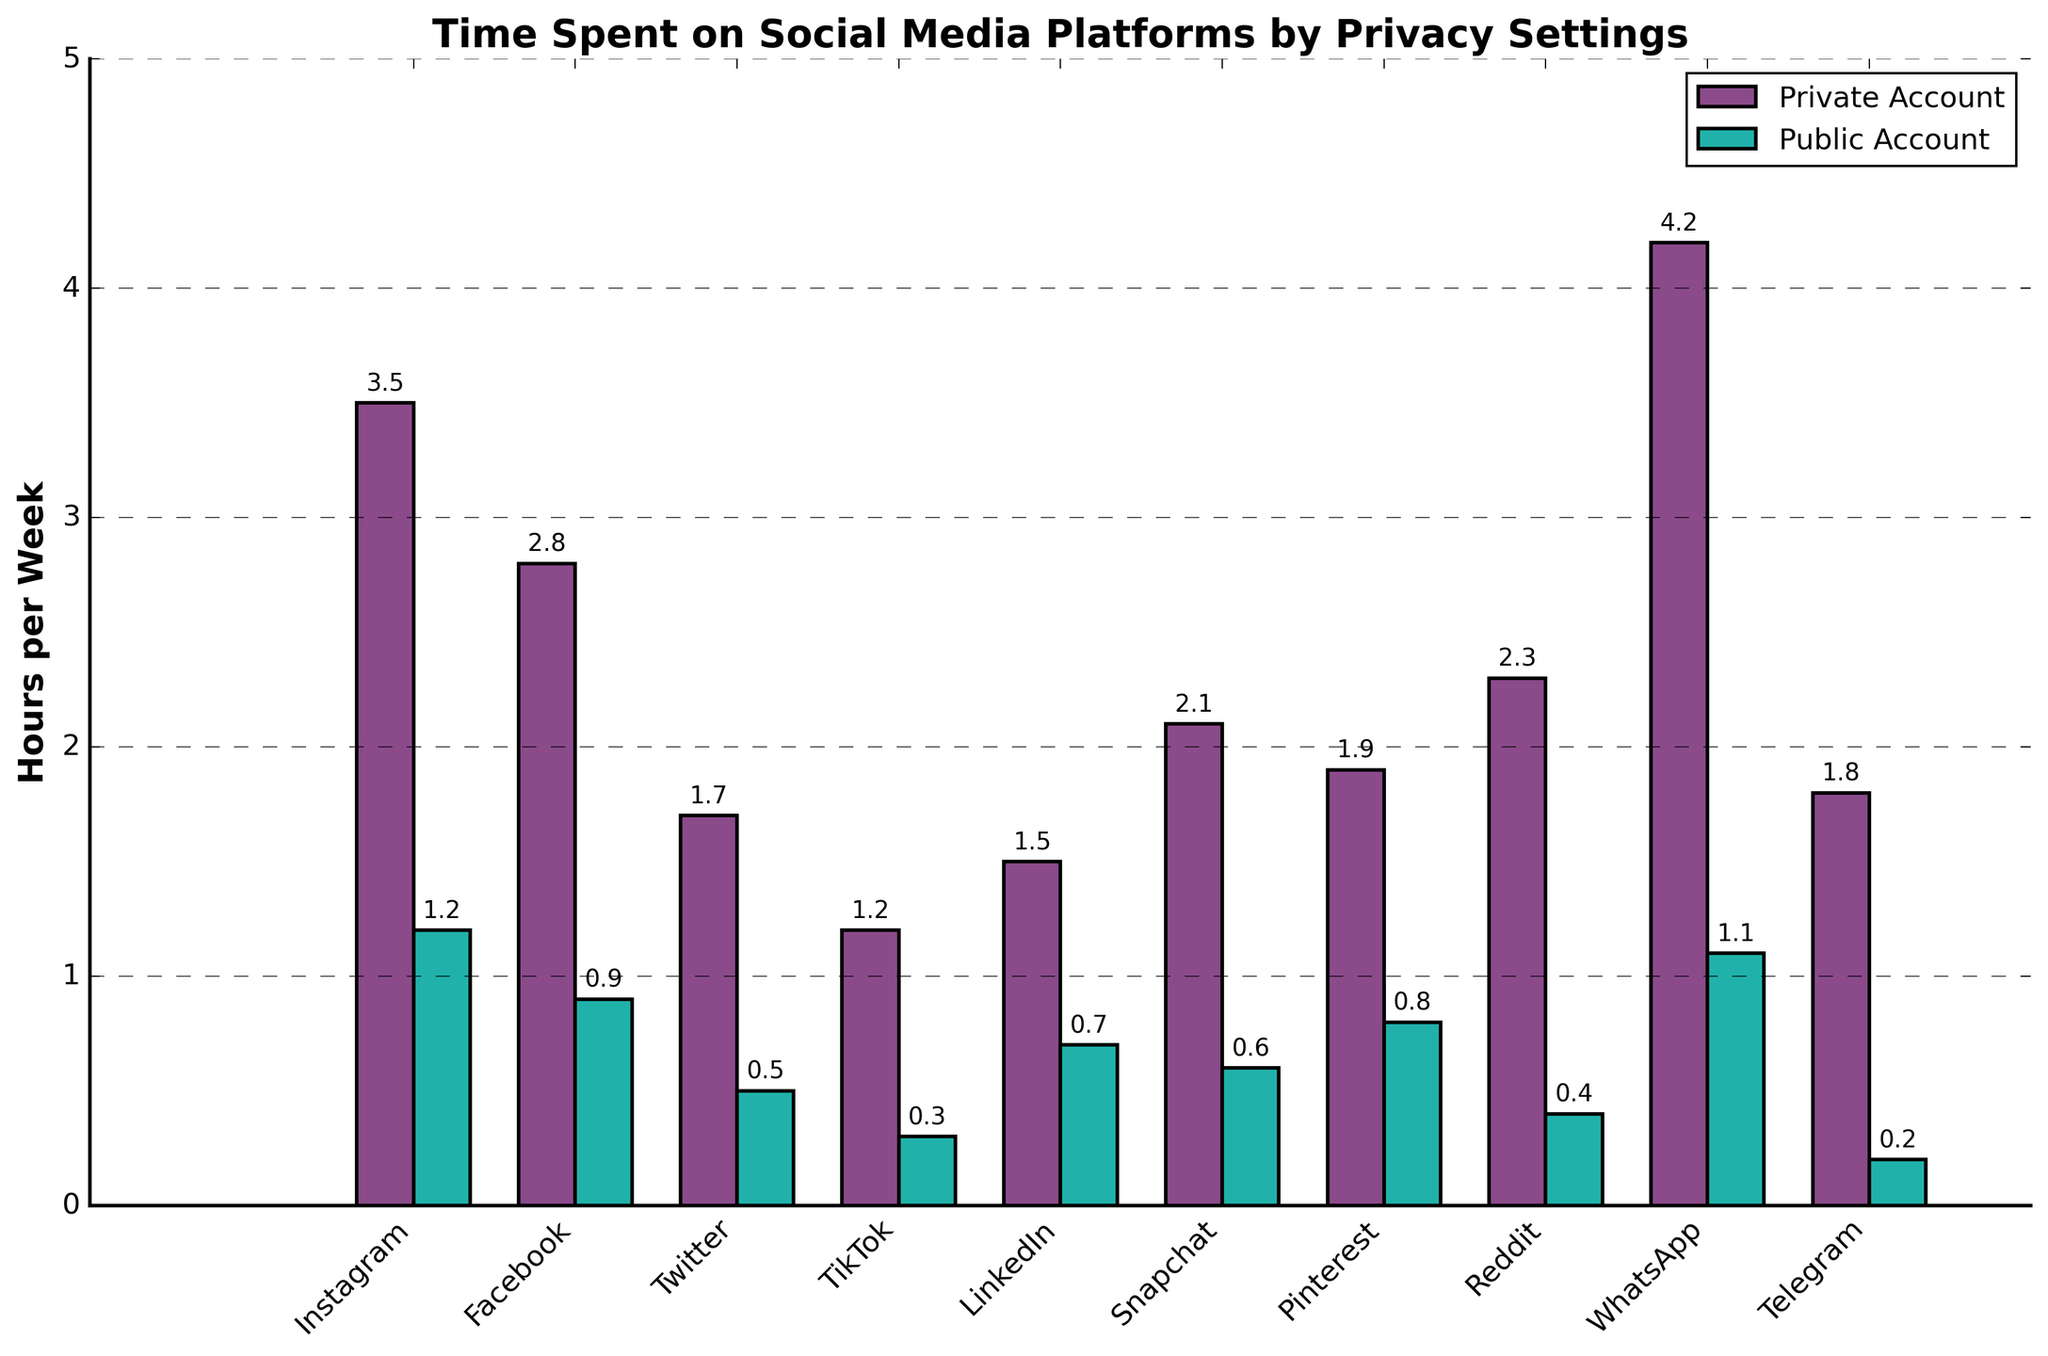Which platform has the highest time spent on private accounts? By visually comparing the heights of the bars for private accounts, the highest bar corresponds to WhatsApp.
Answer: WhatsApp Which platform shows the biggest difference in time spent between private and public accounts? Calculate the difference in hours for each platform and identify the platform with the largest value. For WhatsApp, the difference is 4.2 - 1.1 = 3.1 hours.
Answer: WhatsApp Are there any platforms where the time spent on public accounts is greater than 1 hour per week? Look at the bar heights for public accounts and check if any exceed the 1-hour mark. Only WhatsApp is greater than 1 hour.
Answer: WhatsApp What is the total time spent on Instagram across both privacy settings? Sum the time spent on private and public accounts for Instagram: 3.5 + 1.2 = 4.7 hours.
Answer: 4.7 hours Which platforms have a smaller time difference between private and public accounts compared to LinkedIn? Calculate the difference for LinkedIn (1.5 - 0.7 = 0.8) and compare with other platforms. TikTok (1.2 - 0.3 = 0.9) is close but larger, so no other platforms fall below this difference.
Answer: None How many platforms have time spent on public accounts below 0.5 hours? Count the bars for public accounts that are below 0.5 hours. These are Twitter (0.5), TikTok (0.3), Reddit (0.4), and Telegram (0.2).
Answer: 4 platforms Which platform has the smallest time spent on public accounts? Find the shortest bar in the public accounts category, which corresponds to Telegram at 0.2 hours.
Answer: Telegram What is the average time spent on public accounts per platform? Sum the hours for all public accounts and divide by the number of platforms: (1.2 + 0.9 + 0.5 + 0.3 + 0.7 + 0.6 + 0.8 + 0.4 + 1.1 + 0.2) / 10 = 6.7 / 10 = 0.67 hours.
Answer: 0.67 hours Which platforms have time spent on private accounts greater than 2 hours? Identify the bars for private accounts that exceed the 2-hour mark. These are Instagram (3.5), Facebook (2.8), Snapchat (2.1), Reddit (2.3), and WhatsApp (4.2).
Answer: 5 platforms 